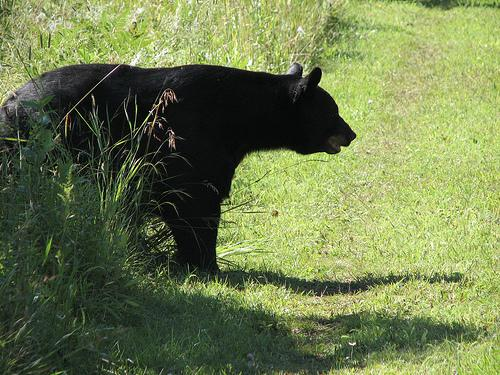Name three different types of plants seen in the image and their respective colors. Green reedy grass, tall grass, and a plant with blue flowers and brown parts are present in the image. Describe the overall sentiment of the image. The image conveys a sense of curiosity and tranquility, as the black bear is surrounded by a picturesque grassy field. Count and describe at least two objects that are neither bear nor grass. Two other objects include white flowers in the grass and brown tracks in the grass. Analyze the interaction between the bear and its environment in the image. The bear is standing in a field, surrounded by various types of grass and vegetation, casting a shadow on the ground, indicating an interaction with the natural environment and sunlight. Provide a detailed description of the primary object in the image. The primary object in the image is a black bear, with pointy ears, curious face, black nose, brown mouth, and teeth showing while standing in a grassy field. How many bears are present in the image and what is their color? There is one black bear in the image. State a complex reasoning question that can be asked about this image. What could be the possible reasons for the bear's curious expression and do the shadows indicate the time of the day? Which part of the bear's body has received sunlight? The bear's snout has received sunlight, indicated by the green grass and sunlit area. Name the parts of the field mentioned in the image and describe the grass. Field parts include the grassy field where the bear is standing, and the green reedy grass, short grass, wispy grass, long grass, and tall weeds in different areas.  What are the shadow objects found in this image? The shadow objects include the shadow of the bear and the shadow of the grass. What is the color of the tracks spotted in the grass from the given image? Brown Is there any noticeable shadow in the image? If so, which objects cast the shadow? Yes, there is a shadow of the bear and the grass in the image. Identify the types of plants surrounding the bear in the image. There are green reedy grass, tall grass, long grass, wispy grass, and a blue flower on a plant. From the given image, determine if it is more likely an urban or nature scene. Nature scene In the given scenario, what type of scenery is behind the bear? Tall grass Describe the grass along with the bear and its snout in the image. Green grass with a black bear snout What color is the bear's fur in the image? Black What color are the flowers seen in the grass around the bear in the image? White and blue Describe an event in the image that involves the bear and its surroundings. The black bear is standing in a sunlit grassy field, casting a shadow on the ground. Based on the information provided in the image, what kind of field is the bear going to? A field with long grass What are the key elements in the scene where the bear is located? A black bear standing in a grassy field, with reedy grass, tall weeds, sun casting a shadow, and white and blue flowers. According to the given image, how is the sunlight affecting the scene? The sun is shining on the grass and casting a shadow of the bear and the grass. Which one of these colors best describes the bear's fur in the image? - a) Brown b) Black c) White d) Grey b) Black Is there any text or number visible in the given image? If yes, provide the text or number. No Based on the provided image, describe the height of the grass around the bear. There is short grass and tall grass surrounding the bear. According to the image, which part of the plant is brown? Part of a plant is brown. Write an aesthetically pleasing caption describing the scene in the image. A black bear majestically stands amidst a sunlit field of verdant grass and vibrant wildflowers. What is the bear doing in the provided image? The bear is standing in a grassy field looking curious. 